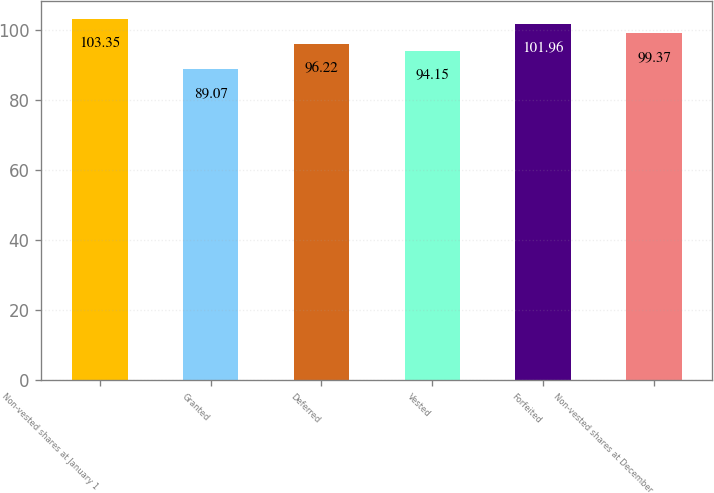<chart> <loc_0><loc_0><loc_500><loc_500><bar_chart><fcel>Non-vested shares at January 1<fcel>Granted<fcel>Deferred<fcel>Vested<fcel>Forfeited<fcel>Non-vested shares at December<nl><fcel>103.35<fcel>89.07<fcel>96.22<fcel>94.15<fcel>101.96<fcel>99.37<nl></chart> 